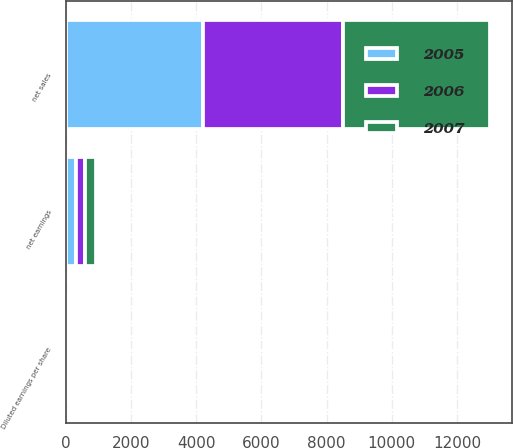Convert chart to OTSL. <chart><loc_0><loc_0><loc_500><loc_500><stacked_bar_chart><ecel><fcel>net sales<fcel>net earnings<fcel>Diluted earnings per share<nl><fcel>2007<fcel>4517.3<fcel>337.3<fcel>4.01<nl><fcel>2006<fcel>4302.7<fcel>292.3<fcel>3.49<nl><fcel>2005<fcel>4208.3<fcel>302<fcel>3.54<nl></chart> 